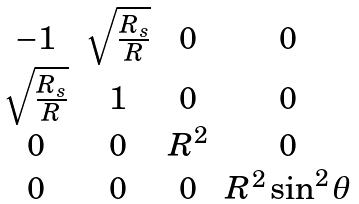<formula> <loc_0><loc_0><loc_500><loc_500>\begin{matrix} - 1 & \sqrt { \frac { R _ { s } } { R } } & 0 & 0 \\ \sqrt { \frac { R _ { s } } { R } } & 1 & 0 & 0 \\ 0 & 0 & R ^ { 2 } & 0 \\ 0 & 0 & 0 & R ^ { 2 } \sin ^ { 2 } \theta \end{matrix}</formula> 